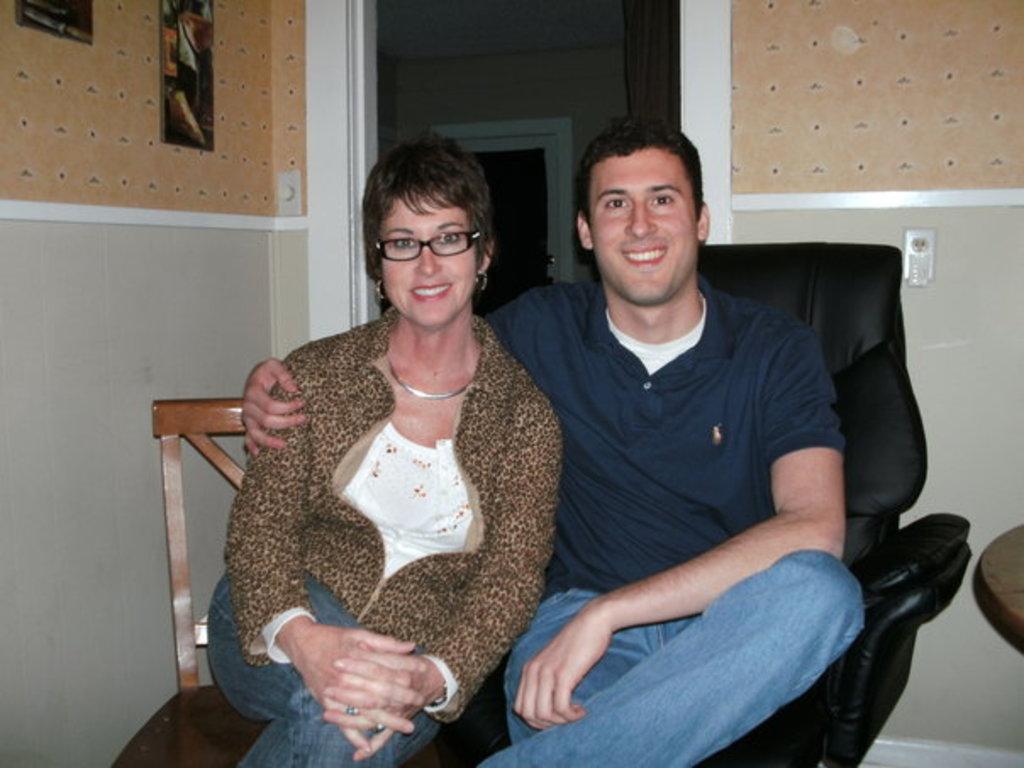Please provide a concise description of this image. In the center of the image we can see man and woman sitting on the chairs. In the background we can see door, curtain and wall. 